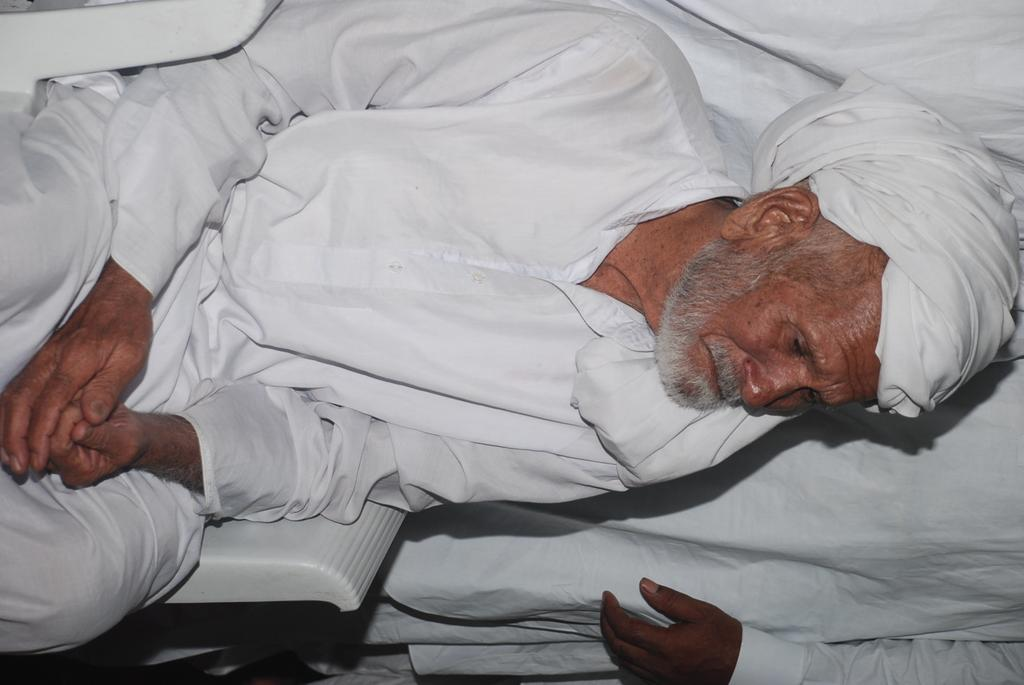How many people are in the image? There are two people in the image. What are the people wearing? Both people are wearing white color dresses. What is the position of one of the people in the image? One person is sitting on a chair. What type of key is the woman holding in the image? There is no key present in the image; both people are wearing white dresses and one person is sitting on a chair. 